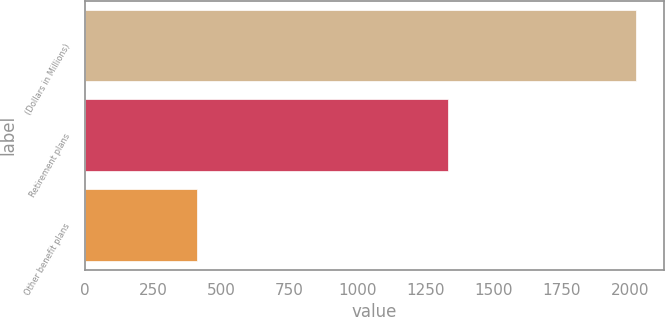Convert chart. <chart><loc_0><loc_0><loc_500><loc_500><bar_chart><fcel>(Dollars in Millions)<fcel>Retirement plans<fcel>Other benefit plans<nl><fcel>2023<fcel>1332<fcel>413<nl></chart> 